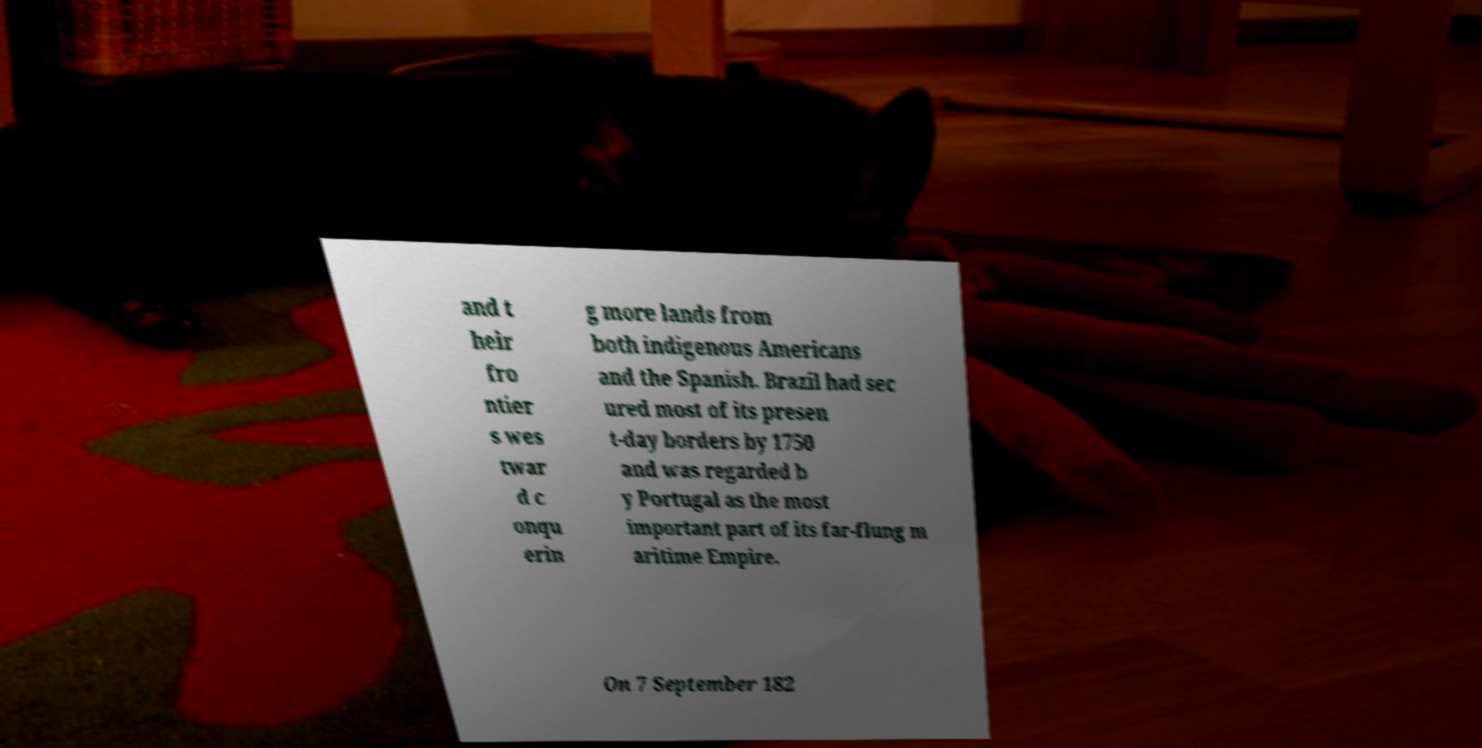Please identify and transcribe the text found in this image. and t heir fro ntier s wes twar d c onqu erin g more lands from both indigenous Americans and the Spanish. Brazil had sec ured most of its presen t-day borders by 1750 and was regarded b y Portugal as the most important part of its far-flung m aritime Empire. On 7 September 182 